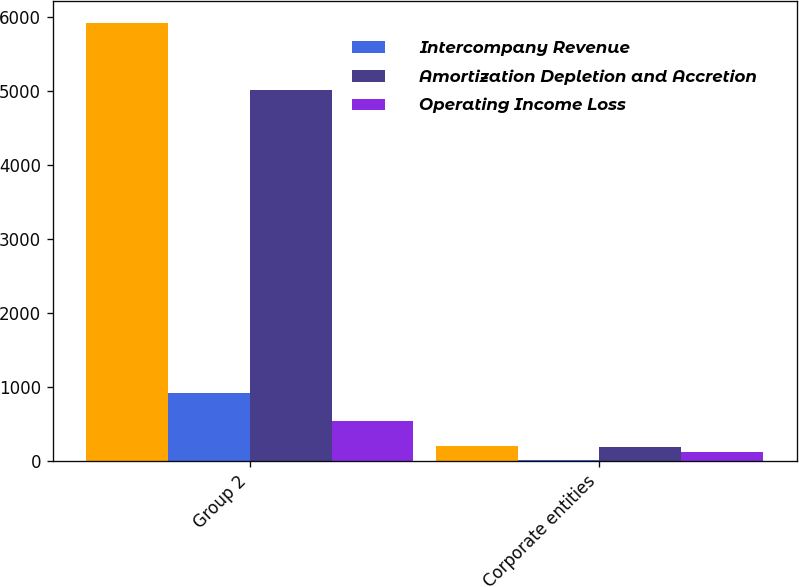Convert chart. <chart><loc_0><loc_0><loc_500><loc_500><stacked_bar_chart><ecel><fcel>Group 2<fcel>Corporate entities<nl><fcel>nan<fcel>5930<fcel>202.5<nl><fcel>Intercompany Revenue<fcel>916.5<fcel>13.6<nl><fcel>Amortization Depletion and Accretion<fcel>5013.5<fcel>188.9<nl><fcel>Operating Income Loss<fcel>538.7<fcel>117.1<nl></chart> 